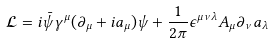Convert formula to latex. <formula><loc_0><loc_0><loc_500><loc_500>\mathcal { L } = i \bar { \psi } { \gamma } ^ { \mu } ( { \partial } _ { \mu } + i a _ { \mu } ) \psi + \frac { 1 } { 2 \pi } { \epsilon } ^ { \mu \nu \lambda } A _ { \mu } { \partial } _ { \nu } a _ { \lambda }</formula> 